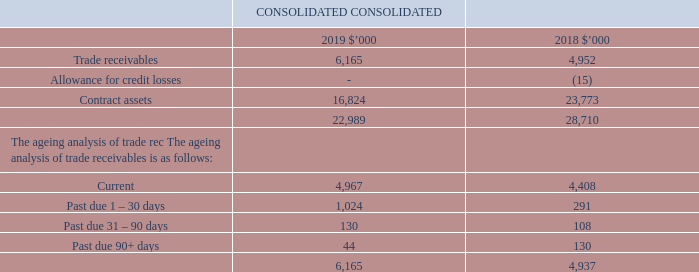3.3 Trade receivables and contract assets
Recognition and measurement
All trade and other receivables recognised as current assets are due for settlement within no more than 30 days for marketing fees and within one year for trail commission. Trade receivables are measured on the basis of amortised cost.
It is the Group’s policy that all key partners who wish to trade on credit terms are subject to credit verification procedures.
Allowance for credit losses
iSelect applies the simplified approach and records lifetime expected losses on all trade receivables and contract assets. As a consequence, we do not track changes in credit risk, but recognise a loss allowance based on lifetime expected credit loss at each reporting date.
iSelect calculates its provision utilising historical credit loss experience, adjusted for other relevant factors, i.e. aging of receivables, credit rating of the debtor, etc. Debts that are known to be uncollectable are written off when identified. If an impairment allowance has been recognised for a debt that becomes uncollectable, the debt is written off against the provision. If an amount is subsequently recovered, it is credited against profit or loss.
As at 30 June 2019, expected credit losses are not considered material.
Contract assets
Contract assets are initially recognised for revenue earned from comparison, purchase support and referral services, as receipt of consideration is conditional on successful completion of a purchase between the customers and the product providers. Upon completion of sale and acceptance by the customer and the provider, invoices are issued to the provider for the amount receivable. These amounts invoiced are reclassified from contract assets to trade receivables. The trade receivable balance represents the Group’s unconditional right to receive the cash.
Key estimates – allowance for credit losses
We apply management judgement to estimate the expected credit losses for trade receivables and contract assets. Expected credit losses are assessed on an ongoing basis. Financial difficulties of the debtor, probability of default, delinquency in payments and credit ratings are utilised in this assessment.
How are trade receivables measured? On the basis of amortised cost. How does the Company recognise a loss allowance? Based on lifetime expected credit loss at each reporting date. How does the Company calculate its provision? Utilising historical credit loss experience, adjusted for other relevant factors, i.e. aging of receivables, credit rating of the debtor, etc. What is the percentage change in the trade receivables from 2018 to 2019?
Answer scale should be: percent. (6,165-4,952)/4,952
Answer: 24.5. What is the percentage change in the contract assets from 2018 to 2019?
Answer scale should be: percent. (16,824-23,773)/23,773
Answer: -29.23. What is the percentage change in the trade receivables past due 90+ days from 2018 to 2019?
Answer scale should be: percent. (44-130)/130
Answer: -66.15. 